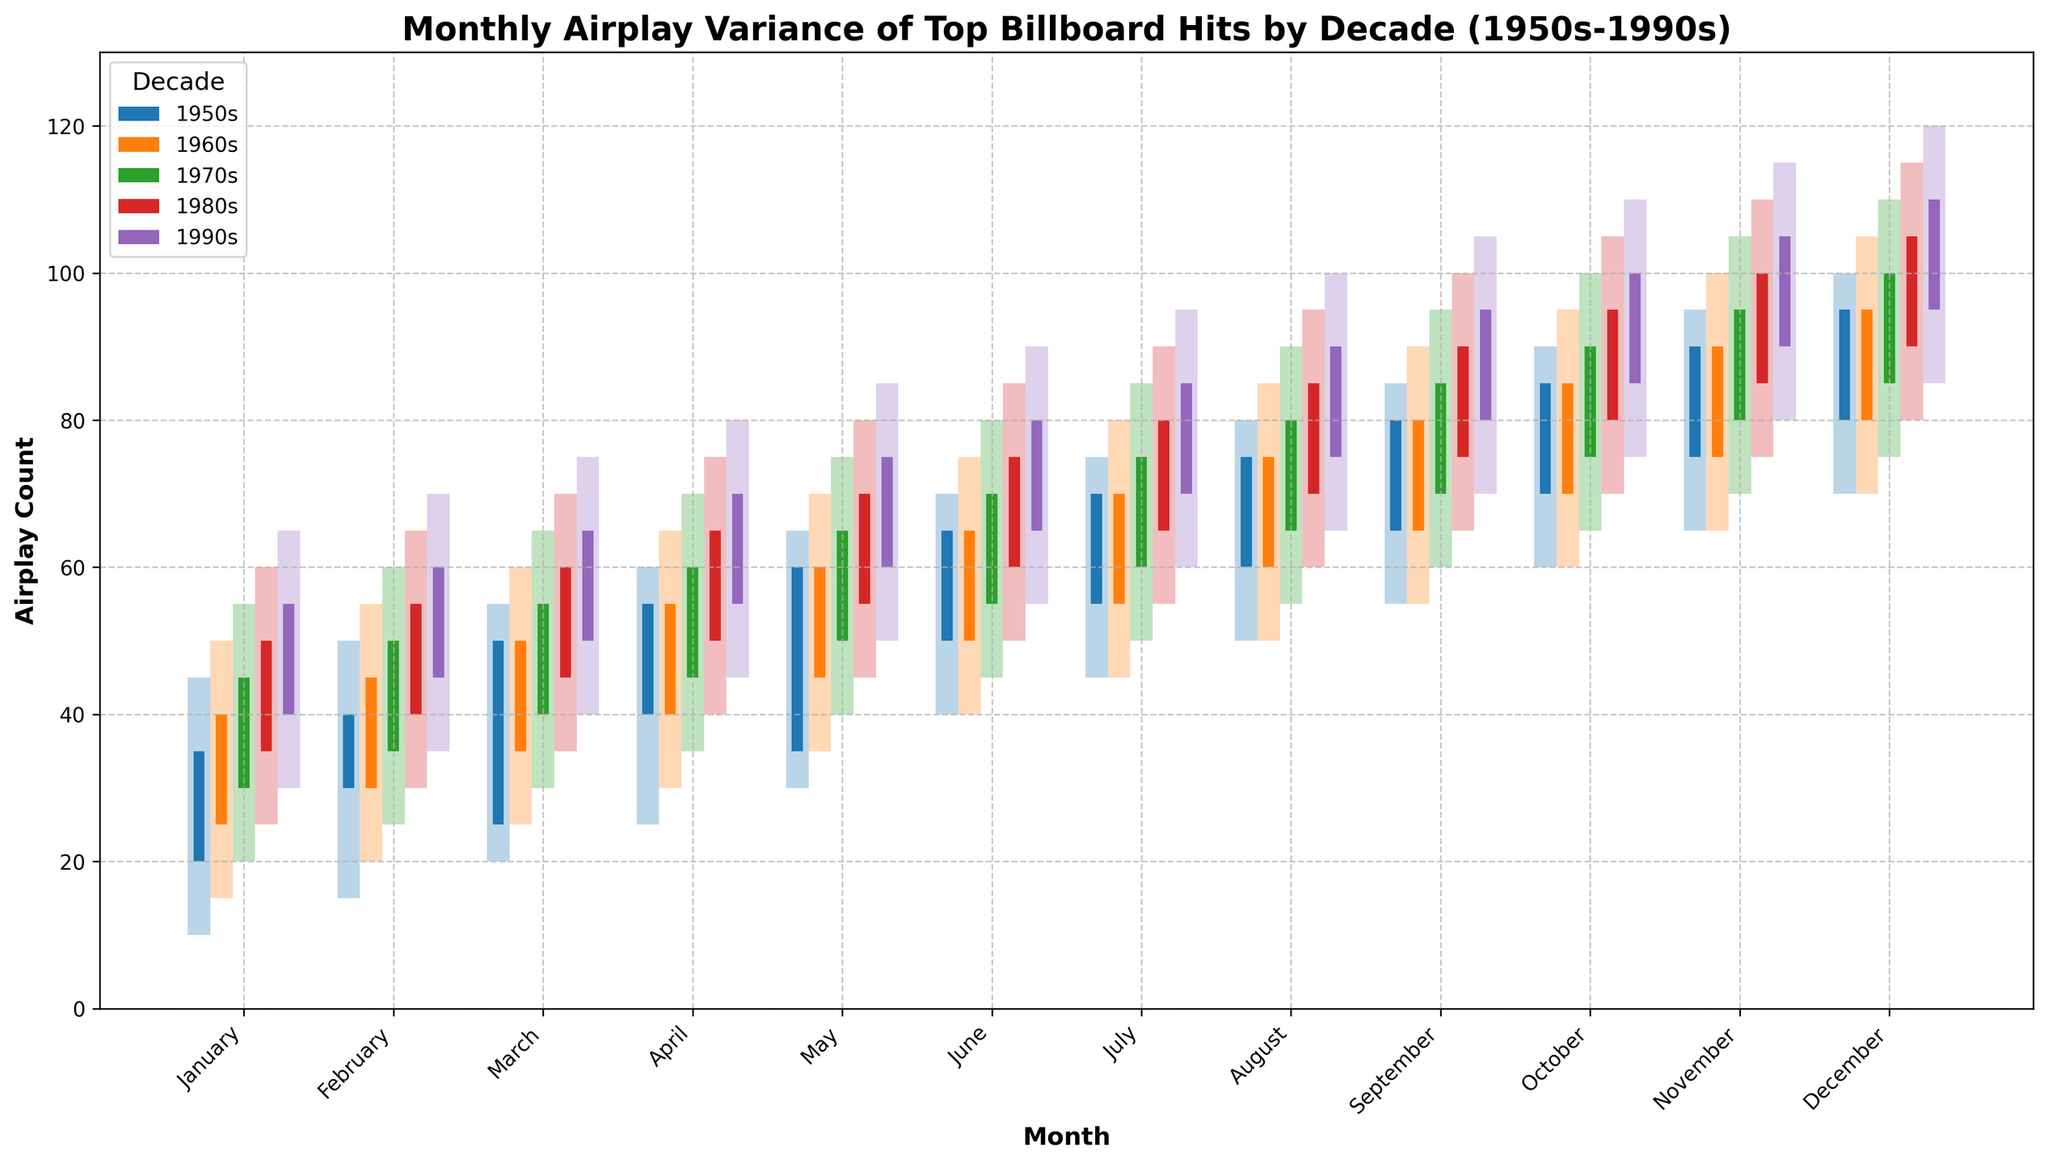What is the title of the plot? The title of the plot is written at the top of the figure.
Answer: Monthly Airplay Variance of Top Billboard Hits by Decade (1950s-1990s) What does the y-axis represent? The label for the y-axis is provided along that axis.
Answer: Airplay Count Which decade has the highest airplay variance in January? Look at the height of the candlestick bars for January across all decades and compare the highest "High" values.
Answer: 1990s In which month did the 1970s have the highest airplay count low? Look for the month where the “Low” value of the candlestick bar for the 1970s is the highest.
Answer: December On average, did the airplay counts increase, decrease, or stay the same over the months from January to December in the 1960s? Observe the trend in the "Open" to "Close" values across months in the 1960s. Calculate the average change per month.
Answer: Increase How does the airplay variance in December compare between the 1950s and 1980s? Compare the difference between the "High" and "Low" values in December for both decades.
Answer: The 1980s have a higher variance Which decade shows the smallest airplay variance in July? Identify the decade with the smallest difference between the "High" and "Low" values in July.
Answer: 1950s What is the difference between the closing airplay counts of November and December in the 1990s? Subtract the "Close" value of November from the "Close" value of December in the 1990s data.
Answer: 5 In which month did the 1980s have their highest airplay count close? Identify the month with the highest "Close" value for the 1980s.
Answer: December Which decade's airplay counts had the largest span (from low to close) in any month? Identify the month and decade with the highest difference between "Low" and "Close" values on the plot.
Answer: 1990s in December 